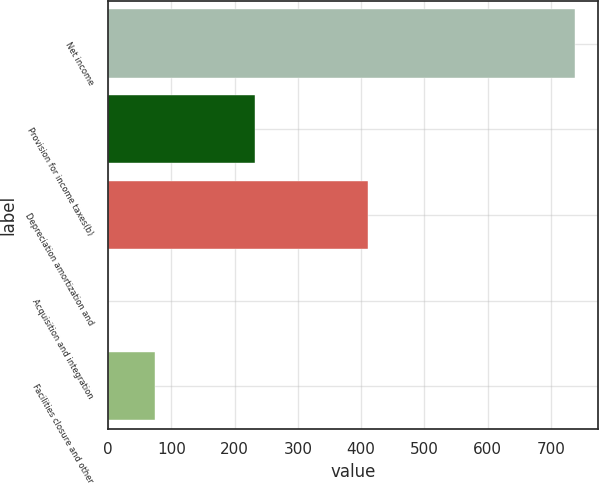Convert chart. <chart><loc_0><loc_0><loc_500><loc_500><bar_chart><fcel>Net income<fcel>Provision for income taxes(b)<fcel>Depreciation amortization and<fcel>Acquisition and integration<fcel>Facilities closure and other<nl><fcel>738<fcel>232.5<fcel>410.9<fcel>0.2<fcel>73.98<nl></chart> 